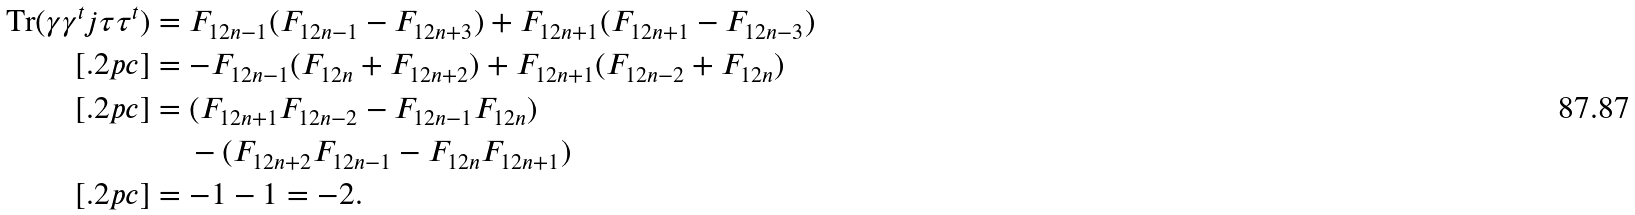Convert formula to latex. <formula><loc_0><loc_0><loc_500><loc_500>\text {Tr} ( \gamma \gamma ^ { t } j \tau \tau ^ { t } ) & = F _ { 1 2 n - 1 } ( F _ { 1 2 n - 1 } - F _ { 1 2 n + 3 } ) + F _ { 1 2 n + 1 } ( F _ { 1 2 n + 1 } - F _ { 1 2 n - 3 } ) \\ [ . 2 p c ] & = - F _ { 1 2 n - 1 } ( F _ { 1 2 n } + F _ { 1 2 n + 2 } ) + F _ { 1 2 n + 1 } ( F _ { 1 2 n - 2 } + F _ { 1 2 n } ) \\ [ . 2 p c ] & = ( F _ { 1 2 n + 1 } F _ { 1 2 n - 2 } - F _ { 1 2 n - 1 } F _ { 1 2 n } ) \\ & \quad \, - ( F _ { 1 2 n + 2 } F _ { 1 2 n - 1 } - F _ { 1 2 n } F _ { 1 2 n + 1 } ) \\ [ . 2 p c ] & = - 1 - 1 = - 2 .</formula> 